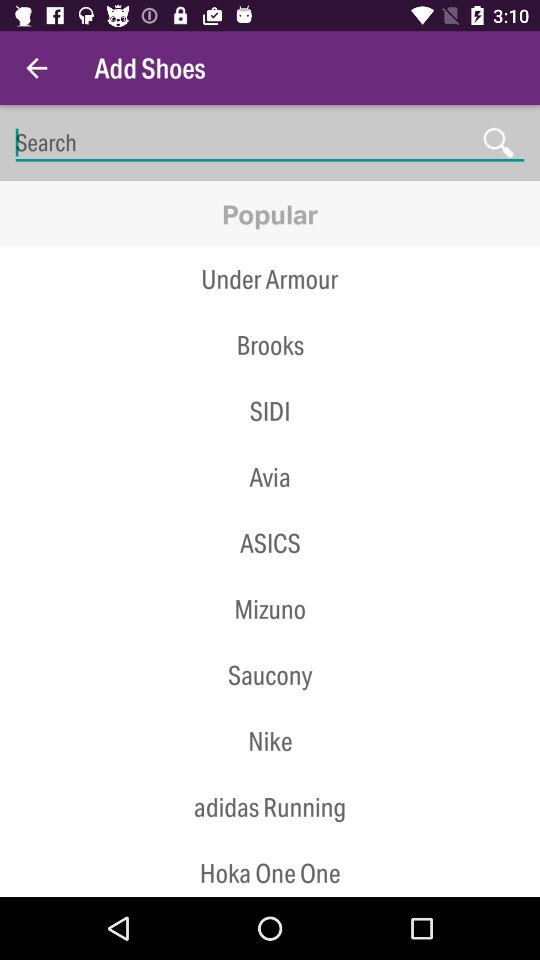What are the options available in the "Popular" category? The available options are "Under Armour", "Brooks", "SIDI", "Avia", "ASICS", "Mizuno", "Saucony", "Nike", "adidas Running" and "Hoka One One". 